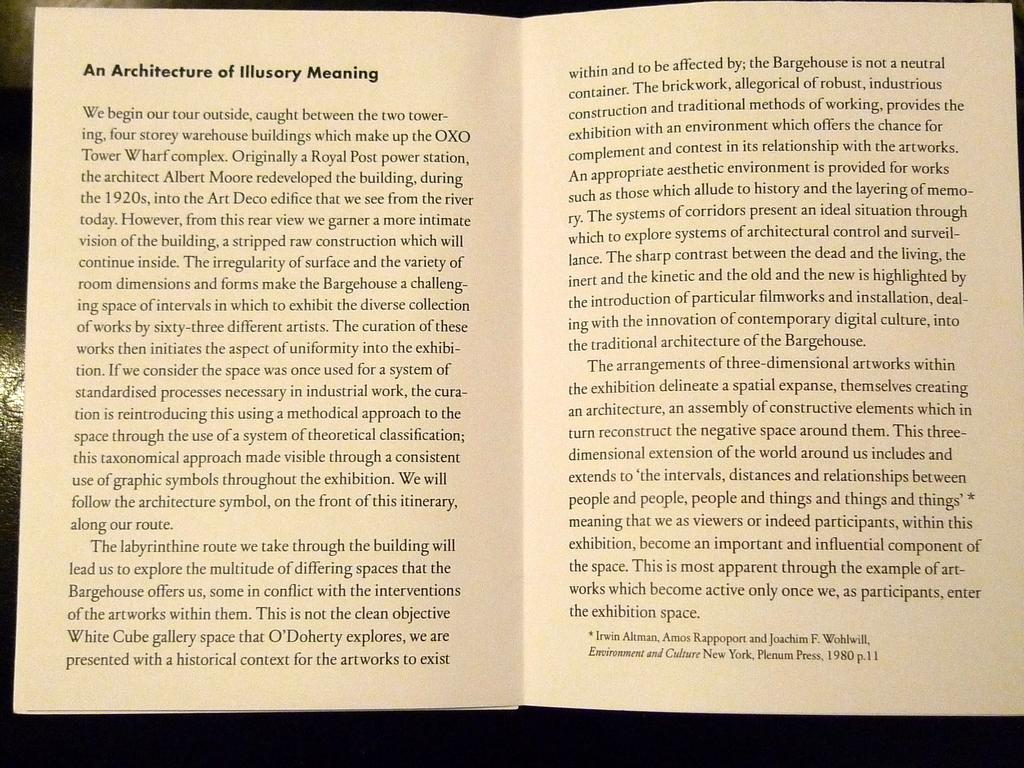<image>
Share a concise interpretation of the image provided. A book is open to the section about Architecture of Illusory Meaning. 